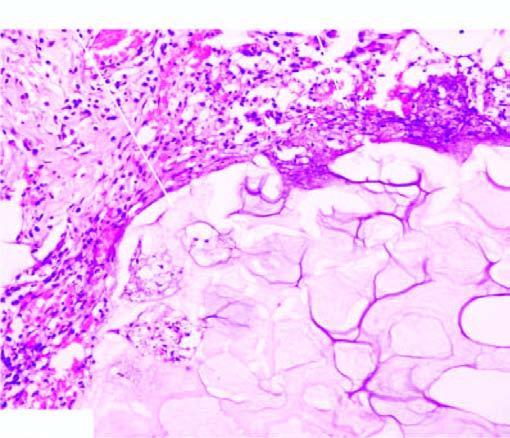what does the periphery show?
Answer the question using a single word or phrase. A few mixed inflammatory cells 